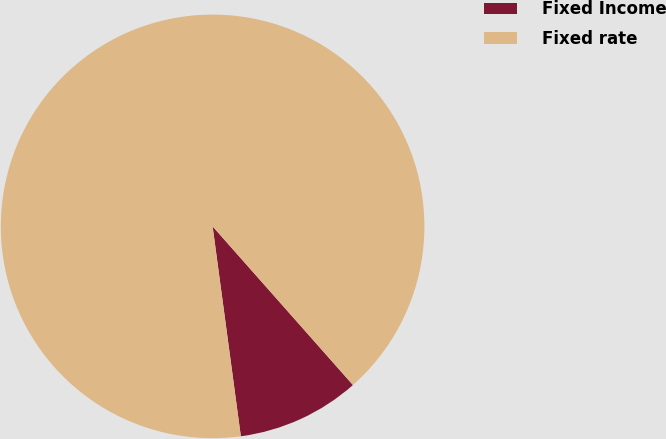Convert chart. <chart><loc_0><loc_0><loc_500><loc_500><pie_chart><fcel>Fixed Income<fcel>Fixed rate<nl><fcel>9.4%<fcel>90.6%<nl></chart> 